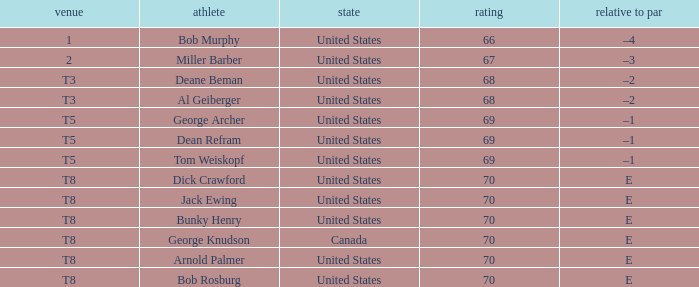When bunky henry from the united states had a score exceeding 67 and an e to par, what was his ranking? T8. 